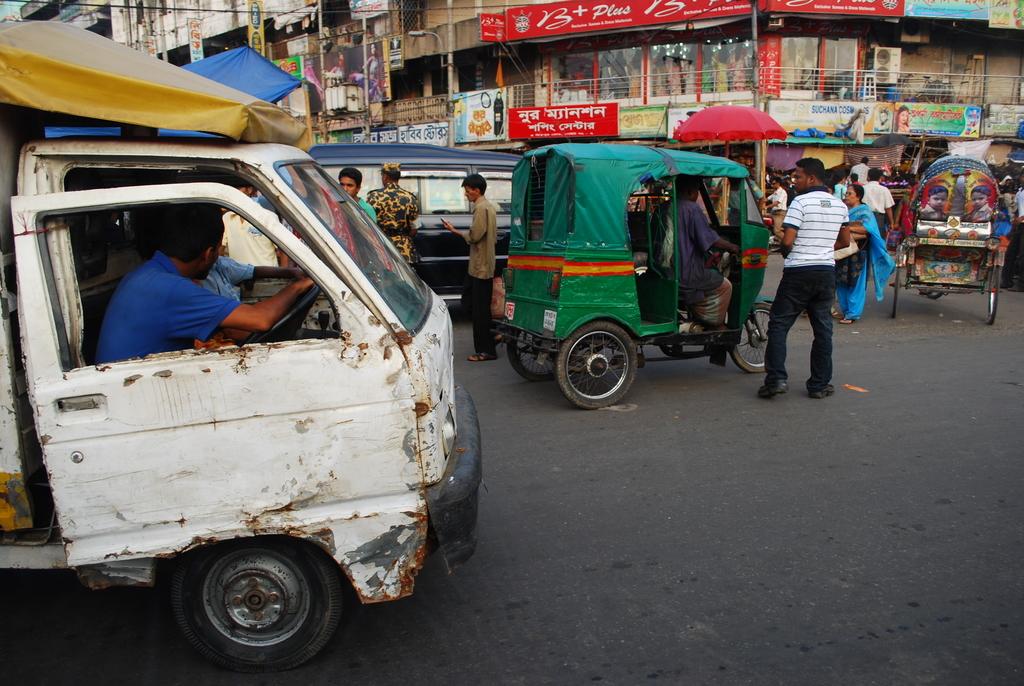What does the red sign say?
Your answer should be very brief. Unanswerable. 